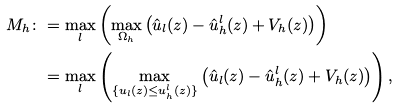Convert formula to latex. <formula><loc_0><loc_0><loc_500><loc_500>M _ { h } \colon & = \max _ { l } \left ( \max _ { \Omega _ { h } } \left ( \hat { u } _ { l } ( z ) - \hat { u } _ { h } ^ { l } ( z ) + V _ { h } ( z ) \right ) \right ) \\ & = \max _ { l } \left ( \max _ { \{ { u } _ { l } ( z ) \leq u _ { h } ^ { l } ( z ) \} } \left ( \hat { u } _ { l } ( z ) - \hat { u } _ { h } ^ { l } ( z ) + V _ { h } ( z ) \right ) \right ) ,</formula> 